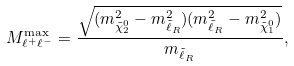Convert formula to latex. <formula><loc_0><loc_0><loc_500><loc_500>M ^ { \max } _ { \ell ^ { + } \ell ^ { - } } = \frac { \sqrt { ( m ^ { 2 } _ { \tilde { \chi } ^ { 0 } _ { 2 } } - m ^ { 2 } _ { \tilde { \ell } _ { R } } ) ( m ^ { 2 } _ { \tilde { \ell } _ { R } } - m ^ { 2 } _ { \tilde { \chi } ^ { 0 } _ { 1 } } ) } } { m _ { \tilde { \ell } _ { R } } } ,</formula> 